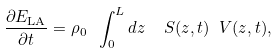Convert formula to latex. <formula><loc_0><loc_0><loc_500><loc_500>\frac { \partial { E } _ { \text {LA} } } { \partial t } = \rho _ { 0 } \ \int _ { 0 } ^ { L } d z \ \ S ( z , t ) \ V ( z , t ) ,</formula> 